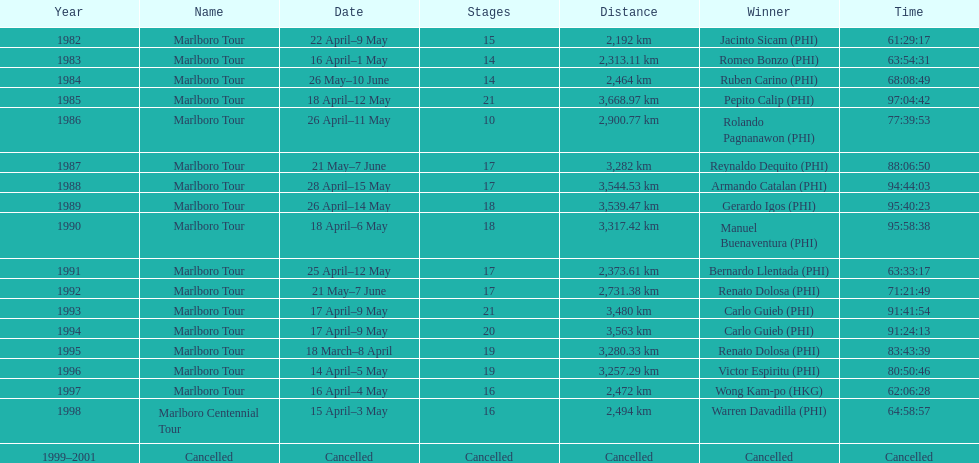Before the tour got canceled, what was the overall count of winners? 17. 